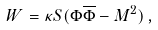Convert formula to latex. <formula><loc_0><loc_0><loc_500><loc_500>W = \kappa S ( \Phi \overline { \Phi } - M ^ { 2 } ) \, ,</formula> 